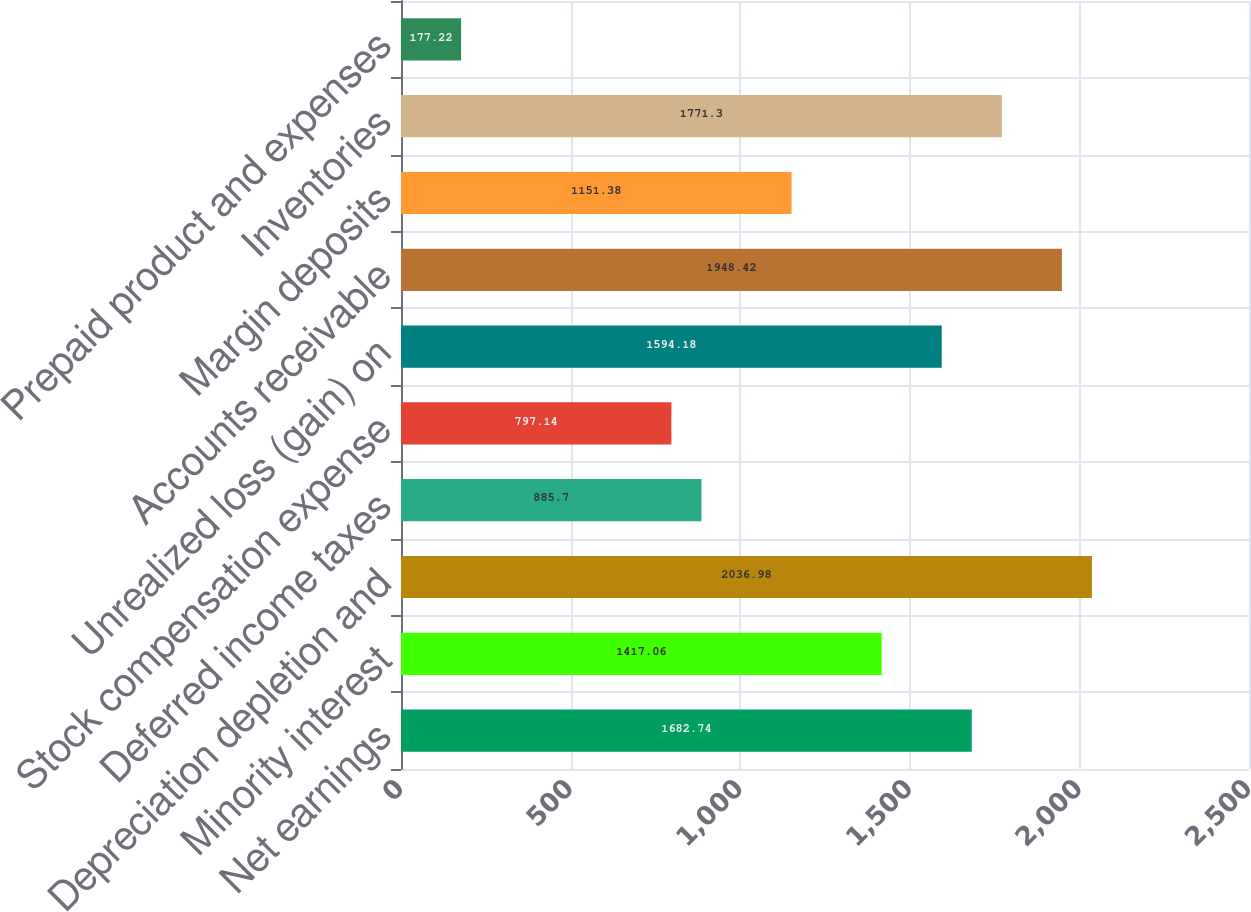<chart> <loc_0><loc_0><loc_500><loc_500><bar_chart><fcel>Net earnings<fcel>Minority interest<fcel>Depreciation depletion and<fcel>Deferred income taxes<fcel>Stock compensation expense<fcel>Unrealized loss (gain) on<fcel>Accounts receivable<fcel>Margin deposits<fcel>Inventories<fcel>Prepaid product and expenses<nl><fcel>1682.74<fcel>1417.06<fcel>2036.98<fcel>885.7<fcel>797.14<fcel>1594.18<fcel>1948.42<fcel>1151.38<fcel>1771.3<fcel>177.22<nl></chart> 